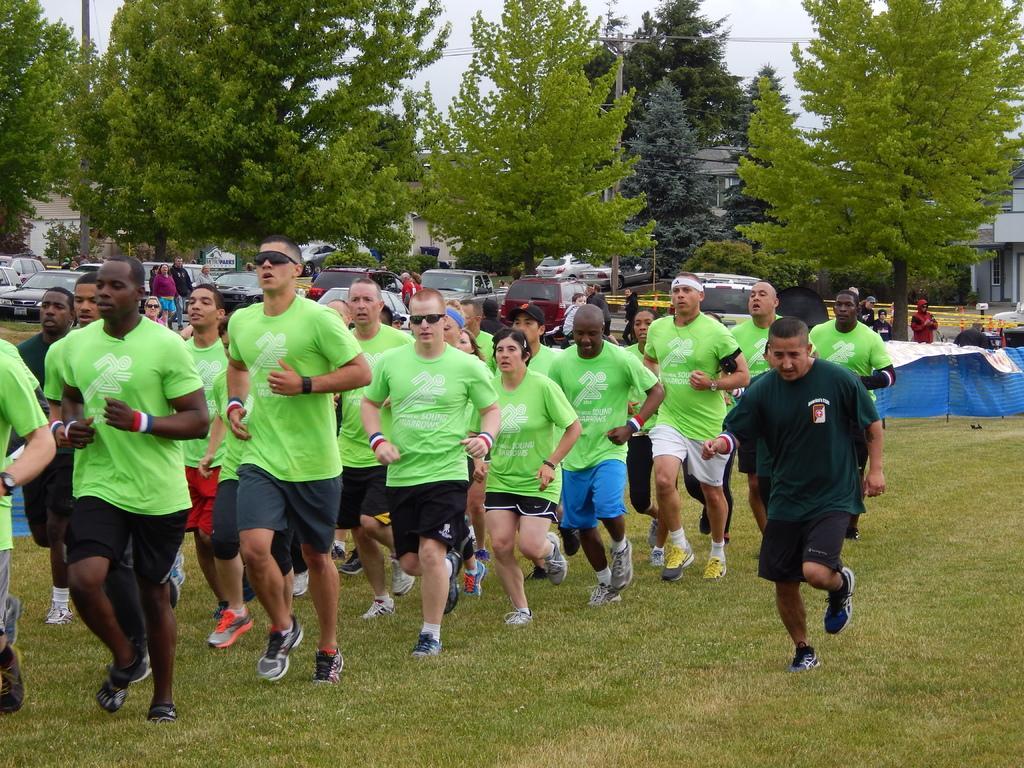In one or two sentences, can you explain what this image depicts? On the left side, there are persons in green color T-shirts running on a ground, on which there is grass. On the right side, there is a person in thick green color T-shirt, running on the ground. In the background, there are vehicles, trees, buildings and there is sky. 